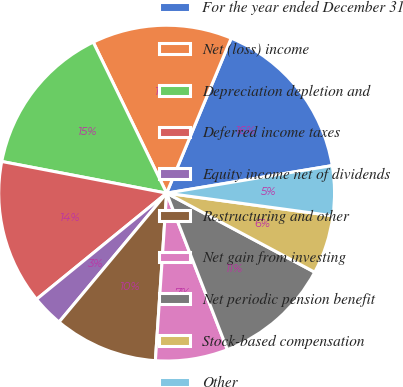Convert chart. <chart><loc_0><loc_0><loc_500><loc_500><pie_chart><fcel>For the year ended December 31<fcel>Net (loss) income<fcel>Depreciation depletion and<fcel>Deferred income taxes<fcel>Equity income net of dividends<fcel>Restructuring and other<fcel>Net gain from investing<fcel>Net periodic pension benefit<fcel>Stock-based compensation<fcel>Other<nl><fcel>16.09%<fcel>13.48%<fcel>14.78%<fcel>13.91%<fcel>3.04%<fcel>10.0%<fcel>6.96%<fcel>11.3%<fcel>5.65%<fcel>4.78%<nl></chart> 